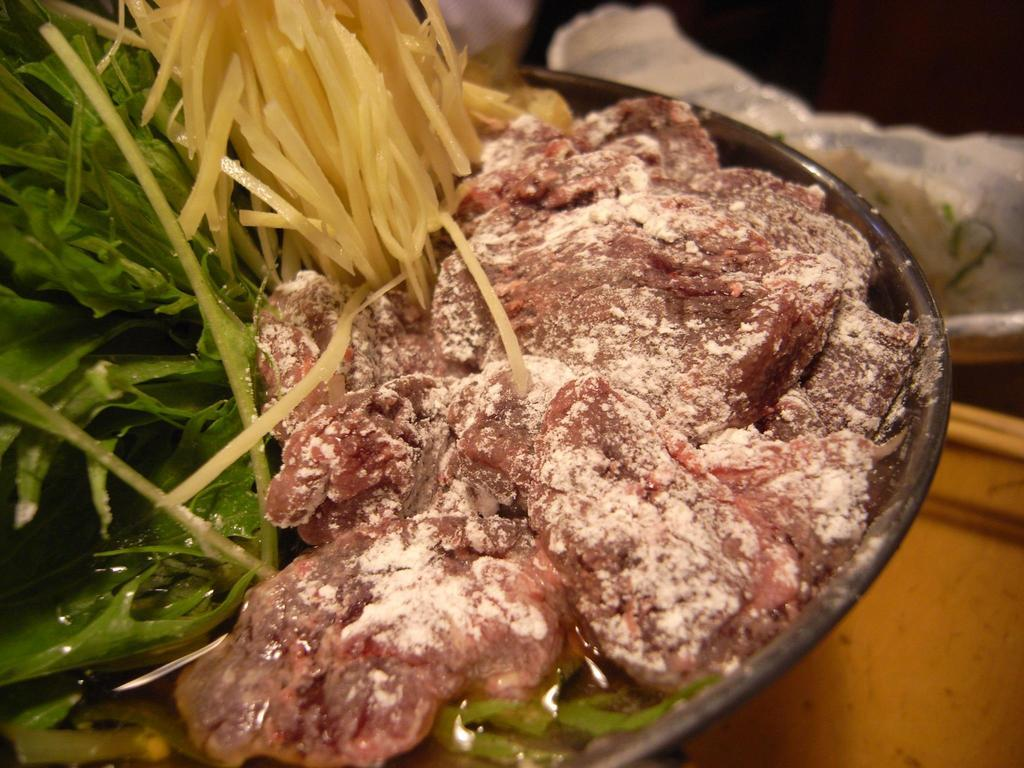What is in the bowl that is visible in the image? There is a bowl with food items in the image. Where is the bowl located in the image? The bowl is placed on a table. What else can be seen beside the bowl in the image? There are objects beside the bowl in the image. What type of sea creature can be seen swimming near the bowl in the image? There is no sea creature present in the image; it features a bowl with food items on a table. What type of church can be seen in the background of the image? There is no church visible in the image; it only shows a bowl with food items on a table. 